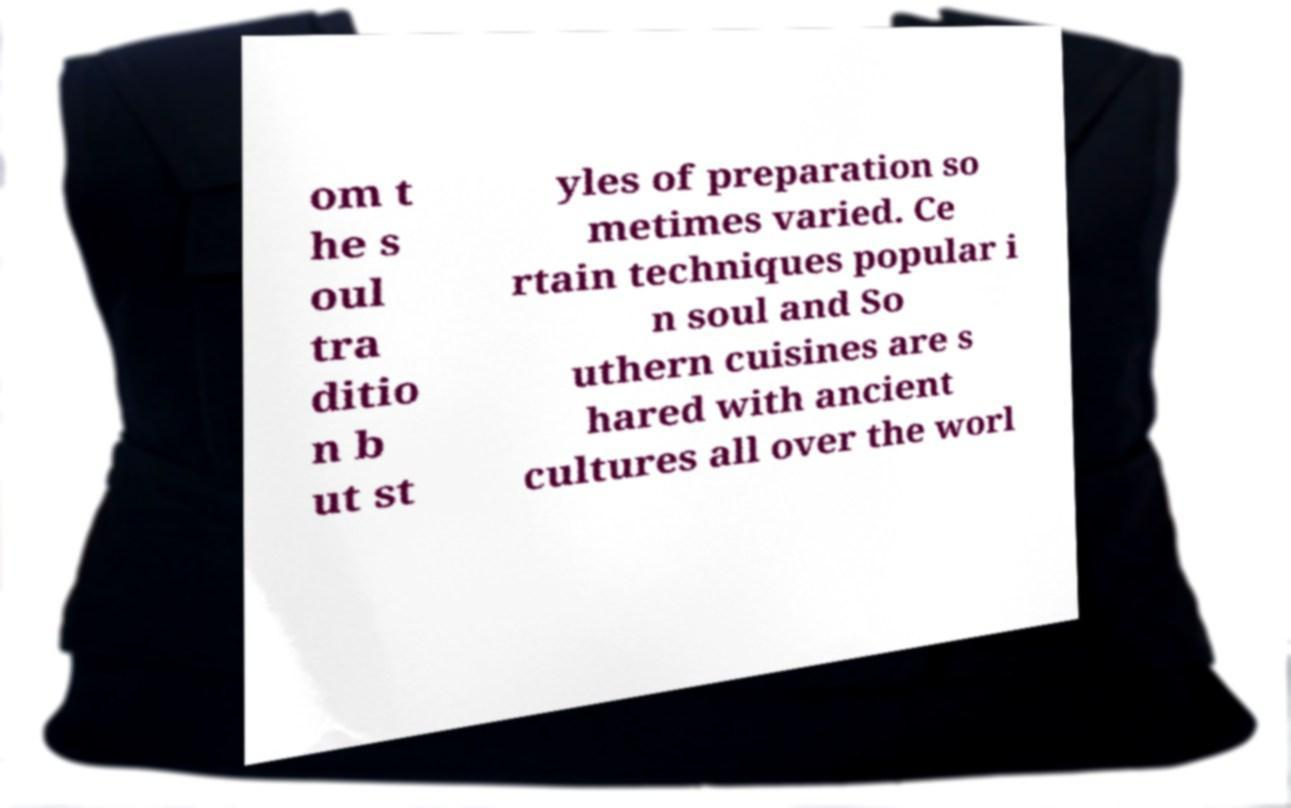What messages or text are displayed in this image? I need them in a readable, typed format. om t he s oul tra ditio n b ut st yles of preparation so metimes varied. Ce rtain techniques popular i n soul and So uthern cuisines are s hared with ancient cultures all over the worl 